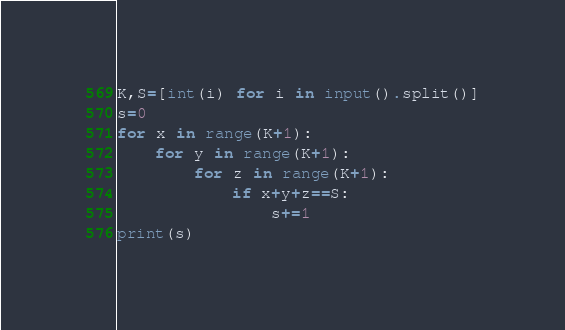Convert code to text. <code><loc_0><loc_0><loc_500><loc_500><_Python_>K,S=[int(i) for i in input().split()]
s=0
for x in range(K+1):
    for y in range(K+1):
        for z in range(K+1):
            if x+y+z==S:
                s+=1
print(s)</code> 